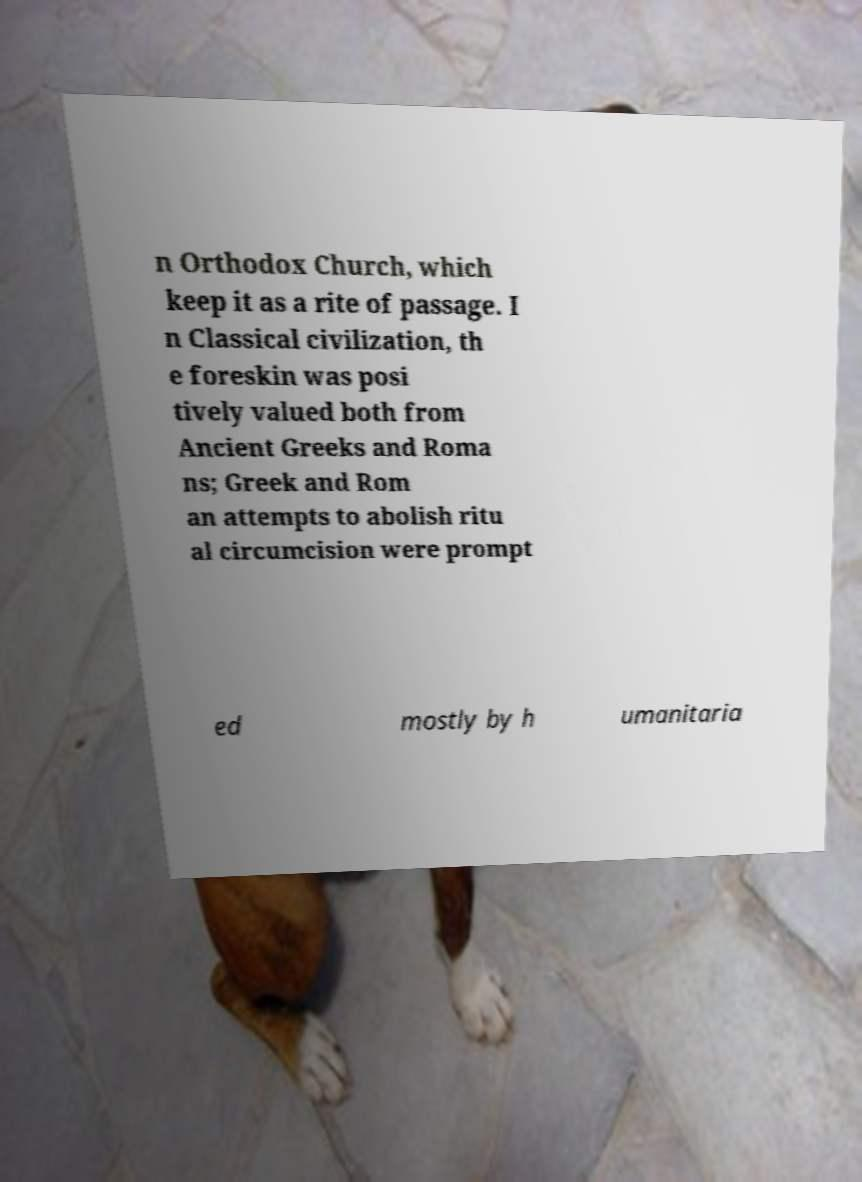What messages or text are displayed in this image? I need them in a readable, typed format. n Orthodox Church, which keep it as a rite of passage. I n Classical civilization, th e foreskin was posi tively valued both from Ancient Greeks and Roma ns; Greek and Rom an attempts to abolish ritu al circumcision were prompt ed mostly by h umanitaria 